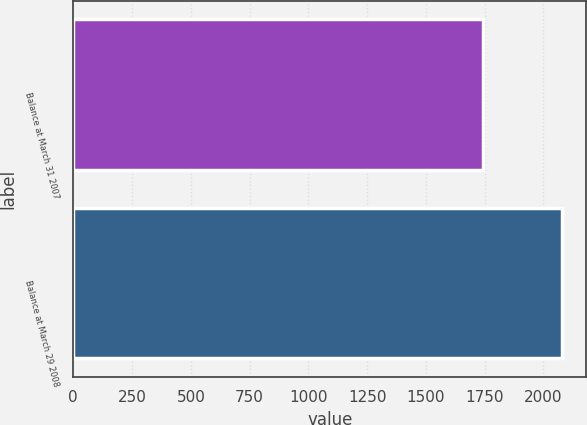Convert chart. <chart><loc_0><loc_0><loc_500><loc_500><bar_chart><fcel>Balance at March 31 2007<fcel>Balance at March 29 2008<nl><fcel>1742.3<fcel>2079.3<nl></chart> 